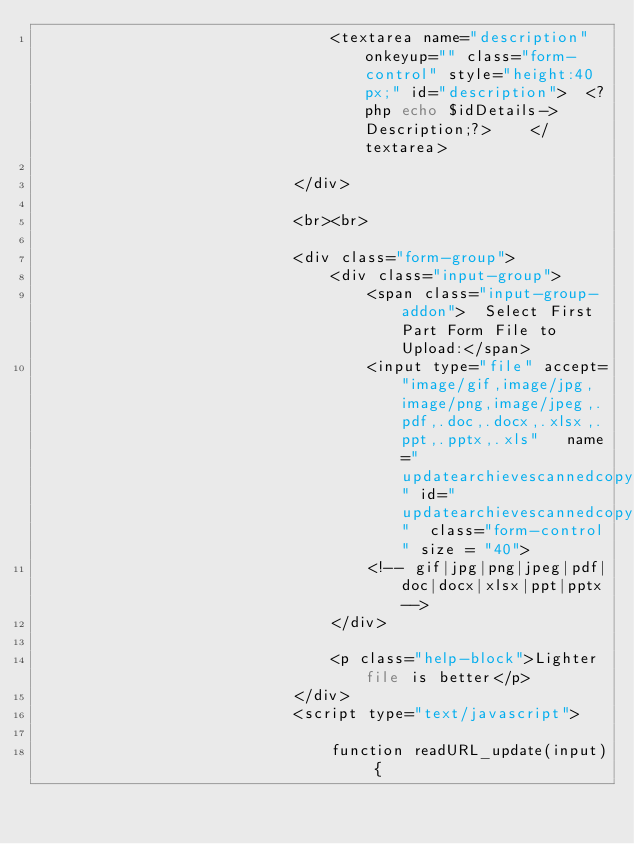<code> <loc_0><loc_0><loc_500><loc_500><_PHP_>                                <textarea name="description" onkeyup="" class="form-control" style="height:40px;" id="description">  <?php echo $idDetails->Description;?>    </textarea>

                            </div>

                            <br><br>

                            <div class="form-group">
                                <div class="input-group">
                                    <span class="input-group-addon">  Select First Part Form File to Upload:</span>
                                    <input type="file" accept="image/gif,image/jpg,image/png,image/jpeg,.pdf,.doc,.docx,.xlsx,.ppt,.pptx,.xls"   name="updatearchievescannedcopy_synopticformreport_firstpage" id="updatearchievescannedcopy_synopticformreport_firstpage"  class="form-control" size = "40">
                                    <!-- gif|jpg|png|jpeg|pdf|doc|docx|xlsx|ppt|pptx-->
                                </div>

                                <p class="help-block">Lighter file is better</p>
                            </div>
                            <script type="text/javascript">

                                function readURL_update(input) {
</code> 